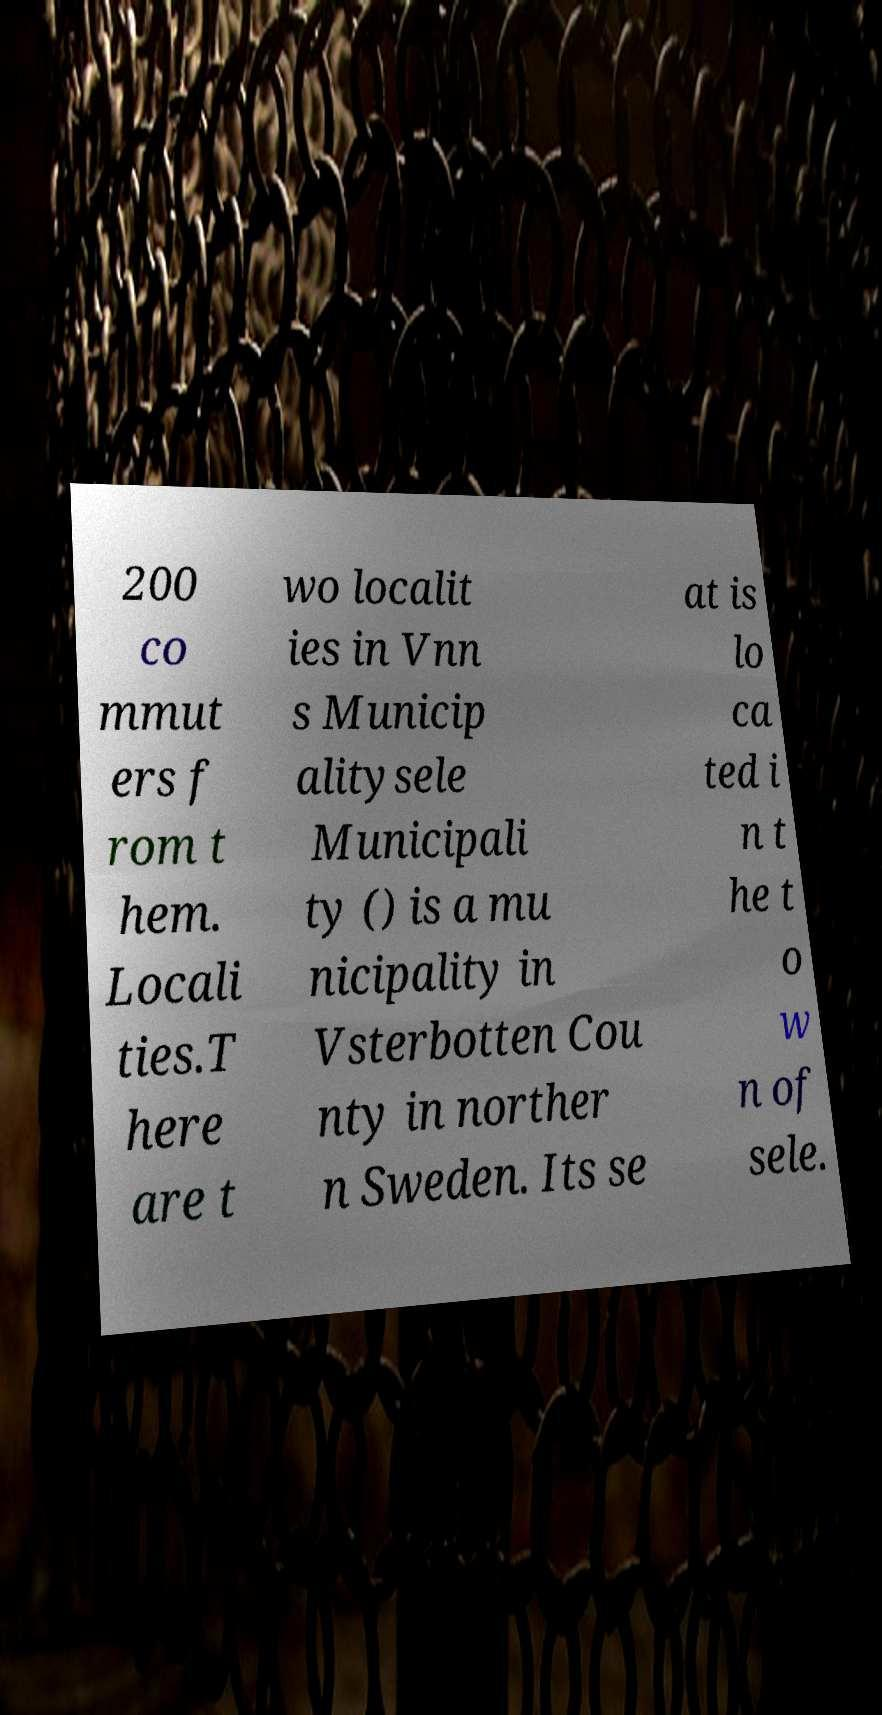There's text embedded in this image that I need extracted. Can you transcribe it verbatim? 200 co mmut ers f rom t hem. Locali ties.T here are t wo localit ies in Vnn s Municip alitysele Municipali ty () is a mu nicipality in Vsterbotten Cou nty in norther n Sweden. Its se at is lo ca ted i n t he t o w n of sele. 